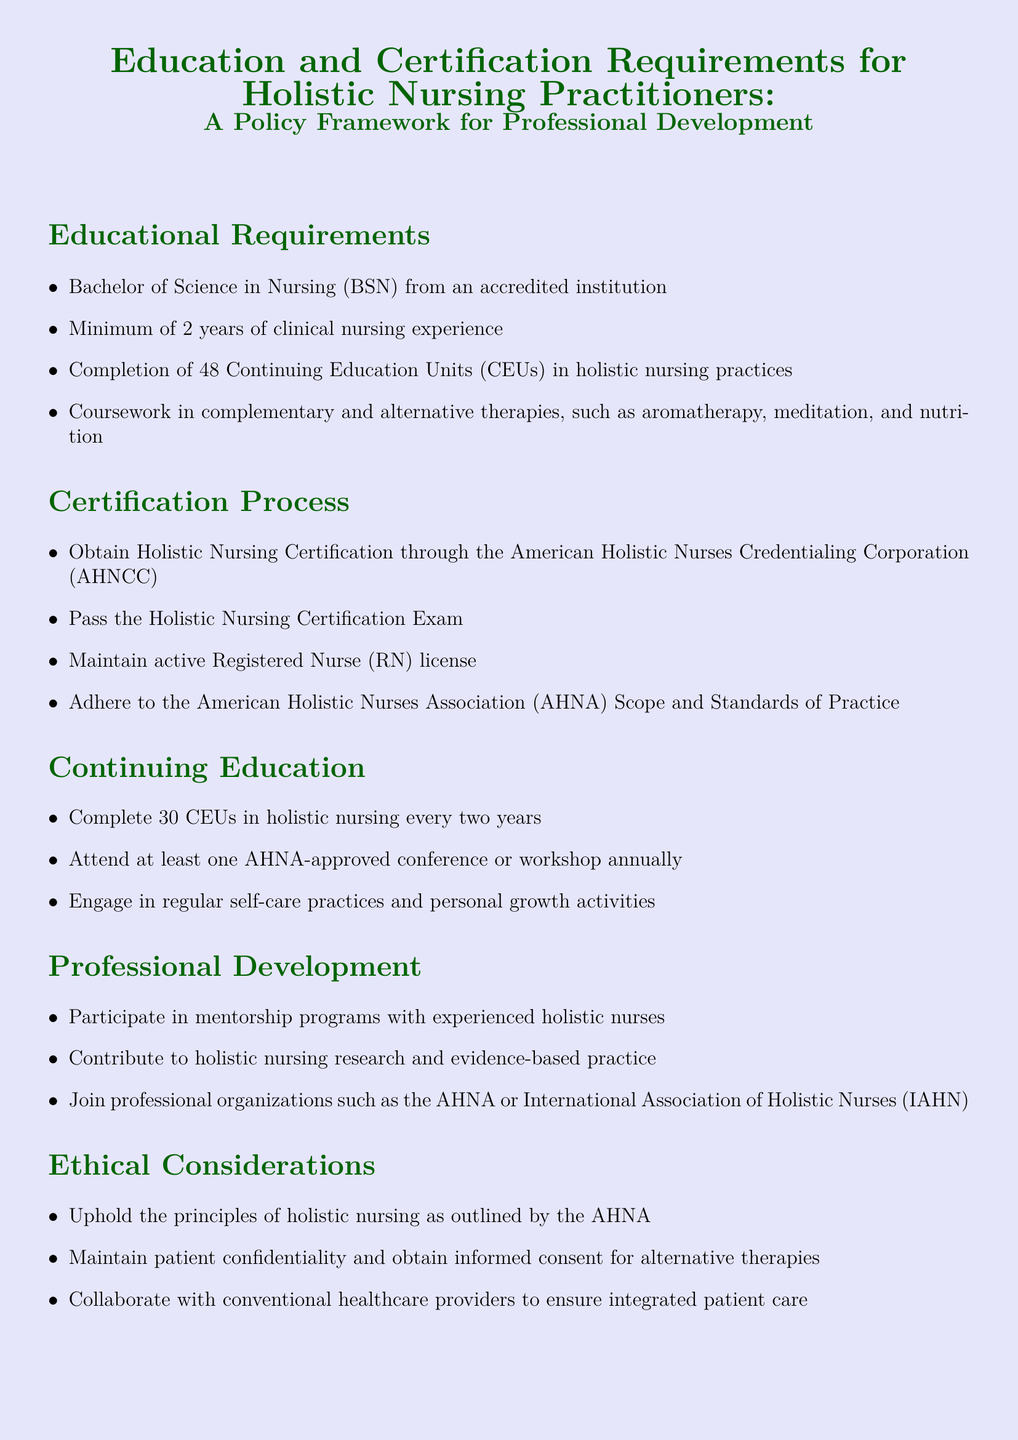What is the required degree for holistic nursing practitioners? The document specifies that a Bachelor of Science in Nursing (BSN) is the required degree for holistic nursing practitioners.
Answer: Bachelor of Science in Nursing (BSN) How many Continuing Education Units (CEUs) are needed for holistic nursing certification? The document states that practitioners must complete 48 Continuing Education Units (CEUs) in holistic nursing practices.
Answer: 48 What certification must be obtained for holistic nursing? The document mentions that holistic nursing certification must be obtained through the American Holistic Nurses Credentialing Corporation (AHNCC).
Answer: American Holistic Nurses Credentialing Corporation How often must holistic nurses complete continuing education? The document specifies that holistic nurses must complete 30 CEUs in holistic nursing every two years.
Answer: Every two years What is one ethical consideration for holistic nurses? The document lists maintaining patient confidentiality and obtaining informed consent as an ethical consideration in holistic nursing.
Answer: Maintain patient confidentiality Why is participation in mentorship programs encouraged? The document suggests that participating in mentorship programs with experienced holistic nurses is beneficial for professional development.
Answer: Professional development How many CEUs must be completed in two years? The document states that holistic nurses must complete 30 CEUs in holistic nursing every two years.
Answer: 30 CEUs What type of therapy courses should nurses complete? The document indicates that coursework in complementary and alternative therapies, such as aromatherapy, meditation, and nutrition, should be completed.
Answer: Complementary and alternative therapies What organization should holistic nurses join for professional development? The document mentions joining professional organizations such as the American Holistic Nurses Association (AHNA) for professional development.
Answer: American Holistic Nurses Association 